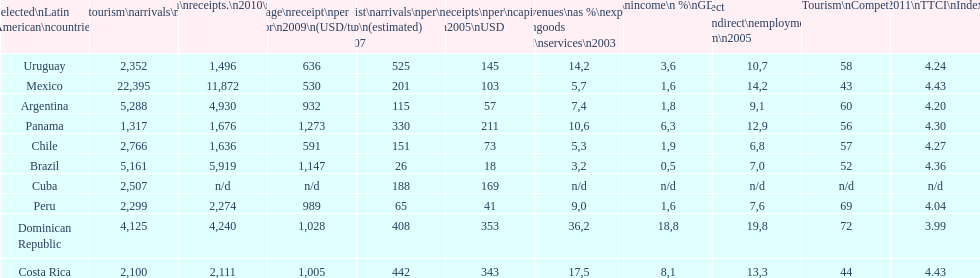What country makes the most tourist income? Dominican Republic. 